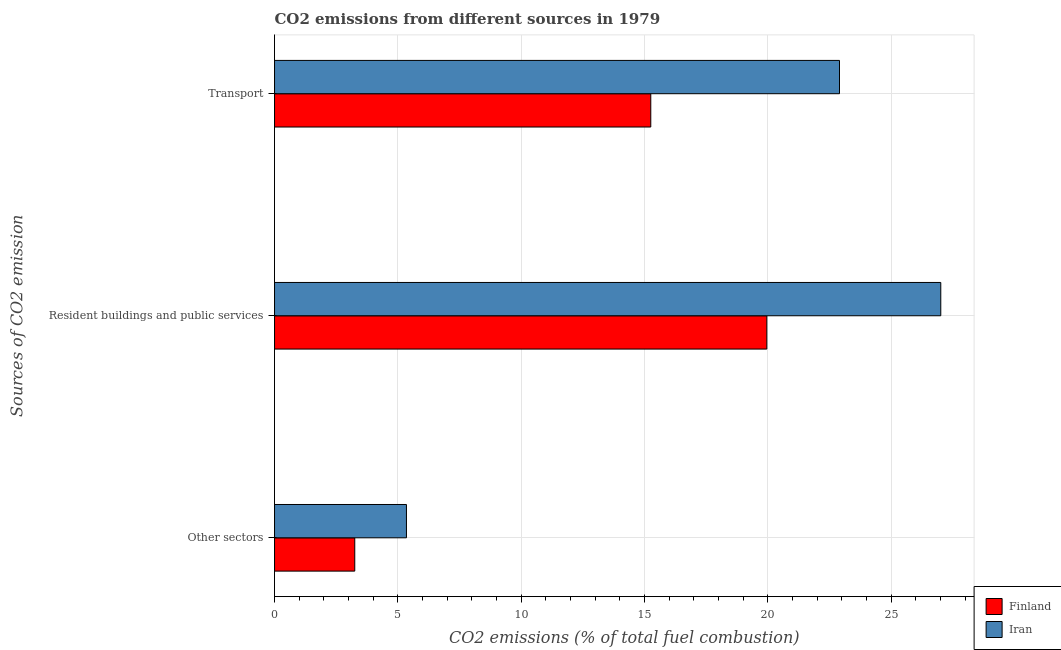How many different coloured bars are there?
Offer a terse response. 2. Are the number of bars on each tick of the Y-axis equal?
Your answer should be very brief. Yes. What is the label of the 1st group of bars from the top?
Offer a very short reply. Transport. What is the percentage of co2 emissions from transport in Finland?
Your response must be concise. 15.25. Across all countries, what is the maximum percentage of co2 emissions from other sectors?
Provide a short and direct response. 5.35. Across all countries, what is the minimum percentage of co2 emissions from other sectors?
Keep it short and to the point. 3.25. In which country was the percentage of co2 emissions from other sectors maximum?
Offer a very short reply. Iran. In which country was the percentage of co2 emissions from other sectors minimum?
Offer a very short reply. Finland. What is the total percentage of co2 emissions from transport in the graph?
Provide a succinct answer. 38.15. What is the difference between the percentage of co2 emissions from transport in Finland and that in Iran?
Your answer should be very brief. -7.65. What is the difference between the percentage of co2 emissions from other sectors in Iran and the percentage of co2 emissions from resident buildings and public services in Finland?
Ensure brevity in your answer.  -14.61. What is the average percentage of co2 emissions from other sectors per country?
Offer a very short reply. 4.3. What is the difference between the percentage of co2 emissions from resident buildings and public services and percentage of co2 emissions from transport in Finland?
Give a very brief answer. 4.7. In how many countries, is the percentage of co2 emissions from resident buildings and public services greater than 17 %?
Offer a terse response. 2. What is the ratio of the percentage of co2 emissions from resident buildings and public services in Iran to that in Finland?
Provide a short and direct response. 1.35. Is the difference between the percentage of co2 emissions from other sectors in Iran and Finland greater than the difference between the percentage of co2 emissions from resident buildings and public services in Iran and Finland?
Provide a succinct answer. No. What is the difference between the highest and the second highest percentage of co2 emissions from resident buildings and public services?
Keep it short and to the point. 7.05. What is the difference between the highest and the lowest percentage of co2 emissions from transport?
Provide a succinct answer. 7.65. In how many countries, is the percentage of co2 emissions from transport greater than the average percentage of co2 emissions from transport taken over all countries?
Keep it short and to the point. 1. Is the sum of the percentage of co2 emissions from other sectors in Finland and Iran greater than the maximum percentage of co2 emissions from transport across all countries?
Offer a very short reply. No. What does the 2nd bar from the bottom in Other sectors represents?
Your answer should be compact. Iran. Is it the case that in every country, the sum of the percentage of co2 emissions from other sectors and percentage of co2 emissions from resident buildings and public services is greater than the percentage of co2 emissions from transport?
Offer a very short reply. Yes. How many bars are there?
Provide a short and direct response. 6. How many countries are there in the graph?
Your answer should be compact. 2. What is the difference between two consecutive major ticks on the X-axis?
Your response must be concise. 5. Does the graph contain grids?
Your response must be concise. Yes. Where does the legend appear in the graph?
Provide a short and direct response. Bottom right. What is the title of the graph?
Your answer should be compact. CO2 emissions from different sources in 1979. What is the label or title of the X-axis?
Provide a short and direct response. CO2 emissions (% of total fuel combustion). What is the label or title of the Y-axis?
Offer a terse response. Sources of CO2 emission. What is the CO2 emissions (% of total fuel combustion) of Finland in Other sectors?
Offer a terse response. 3.25. What is the CO2 emissions (% of total fuel combustion) of Iran in Other sectors?
Your answer should be compact. 5.35. What is the CO2 emissions (% of total fuel combustion) of Finland in Resident buildings and public services?
Your answer should be very brief. 19.96. What is the CO2 emissions (% of total fuel combustion) in Iran in Resident buildings and public services?
Offer a terse response. 27.01. What is the CO2 emissions (% of total fuel combustion) in Finland in Transport?
Offer a terse response. 15.25. What is the CO2 emissions (% of total fuel combustion) in Iran in Transport?
Provide a short and direct response. 22.9. Across all Sources of CO2 emission, what is the maximum CO2 emissions (% of total fuel combustion) in Finland?
Provide a short and direct response. 19.96. Across all Sources of CO2 emission, what is the maximum CO2 emissions (% of total fuel combustion) of Iran?
Ensure brevity in your answer.  27.01. Across all Sources of CO2 emission, what is the minimum CO2 emissions (% of total fuel combustion) of Finland?
Give a very brief answer. 3.25. Across all Sources of CO2 emission, what is the minimum CO2 emissions (% of total fuel combustion) of Iran?
Your answer should be compact. 5.35. What is the total CO2 emissions (% of total fuel combustion) of Finland in the graph?
Provide a succinct answer. 38.46. What is the total CO2 emissions (% of total fuel combustion) in Iran in the graph?
Make the answer very short. 55.26. What is the difference between the CO2 emissions (% of total fuel combustion) of Finland in Other sectors and that in Resident buildings and public services?
Ensure brevity in your answer.  -16.7. What is the difference between the CO2 emissions (% of total fuel combustion) of Iran in Other sectors and that in Resident buildings and public services?
Make the answer very short. -21.66. What is the difference between the CO2 emissions (% of total fuel combustion) of Finland in Other sectors and that in Transport?
Your answer should be compact. -12. What is the difference between the CO2 emissions (% of total fuel combustion) in Iran in Other sectors and that in Transport?
Provide a succinct answer. -17.55. What is the difference between the CO2 emissions (% of total fuel combustion) in Finland in Resident buildings and public services and that in Transport?
Ensure brevity in your answer.  4.7. What is the difference between the CO2 emissions (% of total fuel combustion) in Iran in Resident buildings and public services and that in Transport?
Make the answer very short. 4.11. What is the difference between the CO2 emissions (% of total fuel combustion) of Finland in Other sectors and the CO2 emissions (% of total fuel combustion) of Iran in Resident buildings and public services?
Offer a very short reply. -23.76. What is the difference between the CO2 emissions (% of total fuel combustion) in Finland in Other sectors and the CO2 emissions (% of total fuel combustion) in Iran in Transport?
Make the answer very short. -19.65. What is the difference between the CO2 emissions (% of total fuel combustion) in Finland in Resident buildings and public services and the CO2 emissions (% of total fuel combustion) in Iran in Transport?
Offer a terse response. -2.95. What is the average CO2 emissions (% of total fuel combustion) of Finland per Sources of CO2 emission?
Offer a terse response. 12.82. What is the average CO2 emissions (% of total fuel combustion) of Iran per Sources of CO2 emission?
Your response must be concise. 18.42. What is the difference between the CO2 emissions (% of total fuel combustion) of Finland and CO2 emissions (% of total fuel combustion) of Iran in Other sectors?
Make the answer very short. -2.1. What is the difference between the CO2 emissions (% of total fuel combustion) in Finland and CO2 emissions (% of total fuel combustion) in Iran in Resident buildings and public services?
Make the answer very short. -7.05. What is the difference between the CO2 emissions (% of total fuel combustion) of Finland and CO2 emissions (% of total fuel combustion) of Iran in Transport?
Keep it short and to the point. -7.65. What is the ratio of the CO2 emissions (% of total fuel combustion) in Finland in Other sectors to that in Resident buildings and public services?
Your answer should be compact. 0.16. What is the ratio of the CO2 emissions (% of total fuel combustion) of Iran in Other sectors to that in Resident buildings and public services?
Give a very brief answer. 0.2. What is the ratio of the CO2 emissions (% of total fuel combustion) of Finland in Other sectors to that in Transport?
Make the answer very short. 0.21. What is the ratio of the CO2 emissions (% of total fuel combustion) of Iran in Other sectors to that in Transport?
Give a very brief answer. 0.23. What is the ratio of the CO2 emissions (% of total fuel combustion) in Finland in Resident buildings and public services to that in Transport?
Give a very brief answer. 1.31. What is the ratio of the CO2 emissions (% of total fuel combustion) in Iran in Resident buildings and public services to that in Transport?
Your answer should be compact. 1.18. What is the difference between the highest and the second highest CO2 emissions (% of total fuel combustion) in Finland?
Offer a very short reply. 4.7. What is the difference between the highest and the second highest CO2 emissions (% of total fuel combustion) of Iran?
Keep it short and to the point. 4.11. What is the difference between the highest and the lowest CO2 emissions (% of total fuel combustion) in Finland?
Offer a terse response. 16.7. What is the difference between the highest and the lowest CO2 emissions (% of total fuel combustion) of Iran?
Provide a succinct answer. 21.66. 